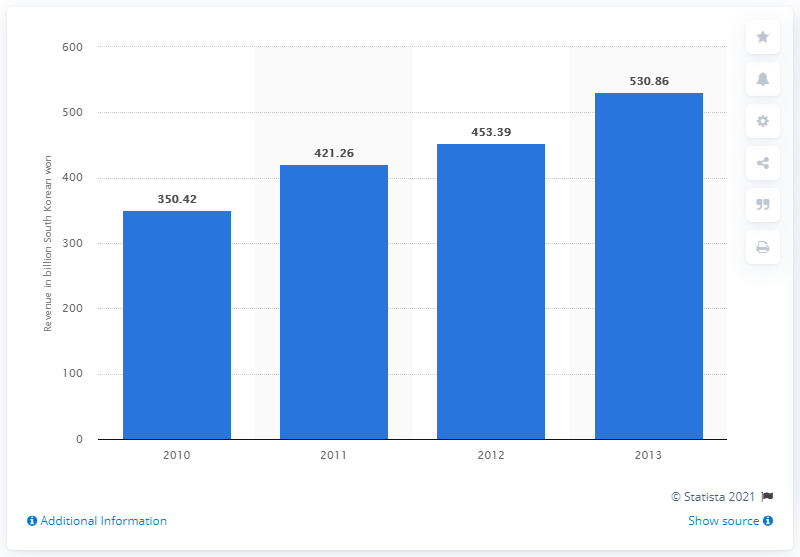Identify some key points in this picture. In 2013, the annual revenue of Daum Communications was approximately 530.86 million U.S. dollars. 